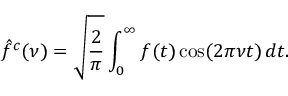Convert formula to latex. <formula><loc_0><loc_0><loc_500><loc_500>{ \hat { f } } ^ { c } ( \nu ) = { \sqrt { \frac { 2 } { \pi } } } \int _ { 0 } ^ { \infty } f ( t ) \cos ( 2 \pi \nu t ) \, d t .</formula> 